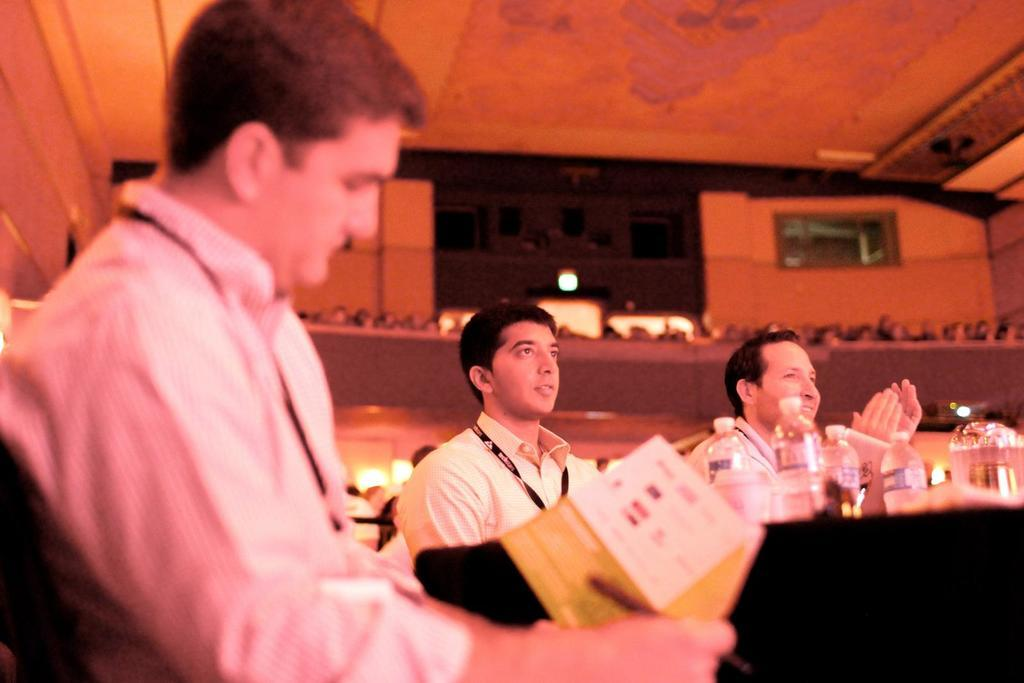How many people are sitting behind the table in the image? There are three men sitting behind the table in the image. What can be seen in the background of the image? Walls are visible in the image. What type of items are present in the image? Disposal bottles and books are visible in the image. Is there any source of natural light in the image? Yes, there is a window in the image. What color is the yak standing next to the table in the image? There is no yak present in the image; it only features three men sitting behind a table. 